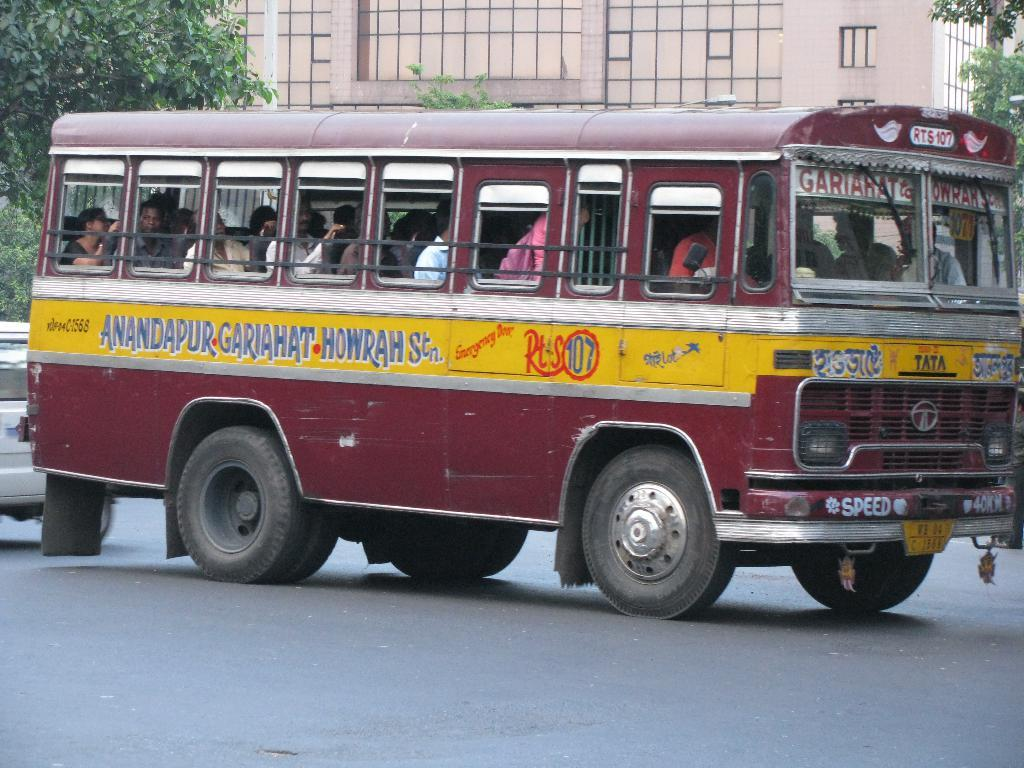Provide a one-sentence caption for the provided image. A run down looking red and yellow bus operates on route 107. 